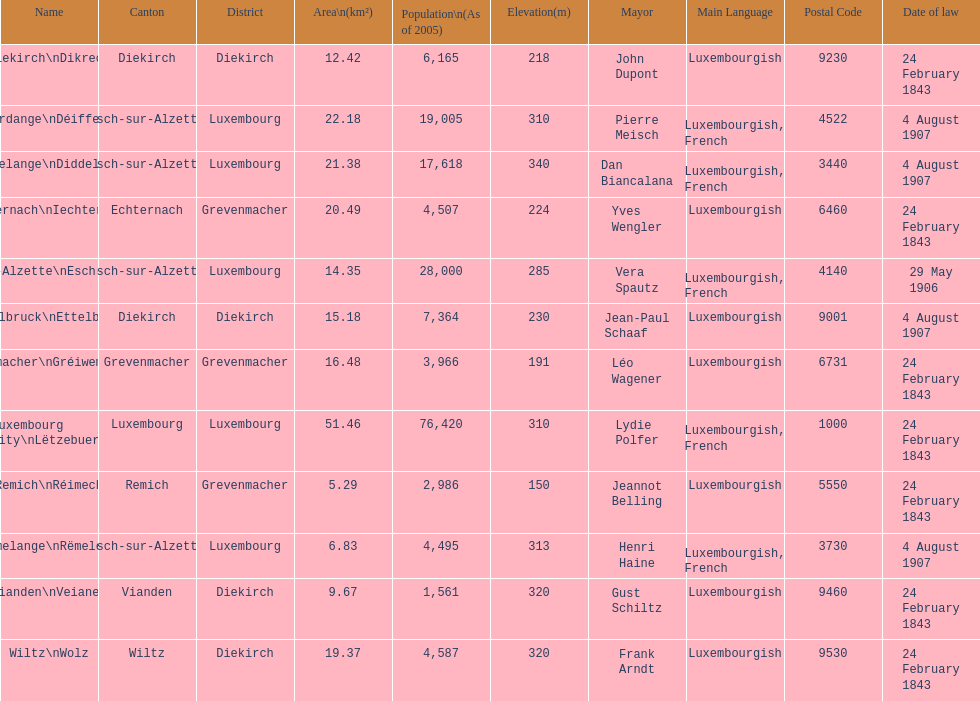How many luxembourg cities had a date of law of feb 24, 1843? 7. Can you parse all the data within this table? {'header': ['Name', 'Canton', 'District', 'Area\\n(km²)', 'Population\\n(As of 2005)', 'Elevation(m)', 'Mayor', 'Main Language', 'Postal Code', 'Date of law'], 'rows': [['Diekirch\\nDikrech', 'Diekirch', 'Diekirch', '12.42', '6,165', '218', 'John Dupont', 'Luxembourgish', '9230', '24 February 1843'], ['Differdange\\nDéifferdeng', 'Esch-sur-Alzette', 'Luxembourg', '22.18', '19,005', '310', 'Pierre Meisch', 'Luxembourgish, French', '4522', '4 August 1907'], ['Dudelange\\nDiddeleng', 'Esch-sur-Alzette', 'Luxembourg', '21.38', '17,618', '340', 'Dan Biancalana', 'Luxembourgish, French', '3440', '4 August 1907'], ['Echternach\\nIechternach', 'Echternach', 'Grevenmacher', '20.49', '4,507', '224', 'Yves Wengler', 'Luxembourgish', '6460', '24 February 1843'], ['Esch-sur-Alzette\\nEsch-Uelzecht', 'Esch-sur-Alzette', 'Luxembourg', '14.35', '28,000', '285', 'Vera Spautz', 'Luxembourgish, French', '4140', '29 May 1906'], ['Ettelbruck\\nEttelbréck', 'Diekirch', 'Diekirch', '15.18', '7,364', '230', 'Jean-Paul Schaaf', 'Luxembourgish', '9001', '4 August 1907'], ['Grevenmacher\\nGréiwemaacher', 'Grevenmacher', 'Grevenmacher', '16.48', '3,966', '191', 'Léo Wagener', 'Luxembourgish', '6731', '24 February 1843'], ['Luxembourg City\\nLëtzebuerg', 'Luxembourg', 'Luxembourg', '51.46', '76,420', '310', 'Lydie Polfer', 'Luxembourgish, French', '1000', '24 February 1843'], ['Remich\\nRéimech', 'Remich', 'Grevenmacher', '5.29', '2,986', '150', 'Jeannot Belling', 'Luxembourgish', '5550', '24 February 1843'], ['Rumelange\\nRëmeleng', 'Esch-sur-Alzette', 'Luxembourg', '6.83', '4,495', '313', 'Henri Haine', 'Luxembourgish, French', '3730', '4 August 1907'], ['Vianden\\nVeianen', 'Vianden', 'Diekirch', '9.67', '1,561', '320', 'Gust Schiltz', 'Luxembourgish', '9460', '24 February 1843'], ['Wiltz\\nWolz', 'Wiltz', 'Diekirch', '19.37', '4,587', '320', 'Frank Arndt', 'Luxembourgish', '9530', '24 February 1843']]} 